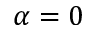Convert formula to latex. <formula><loc_0><loc_0><loc_500><loc_500>\alpha = 0</formula> 